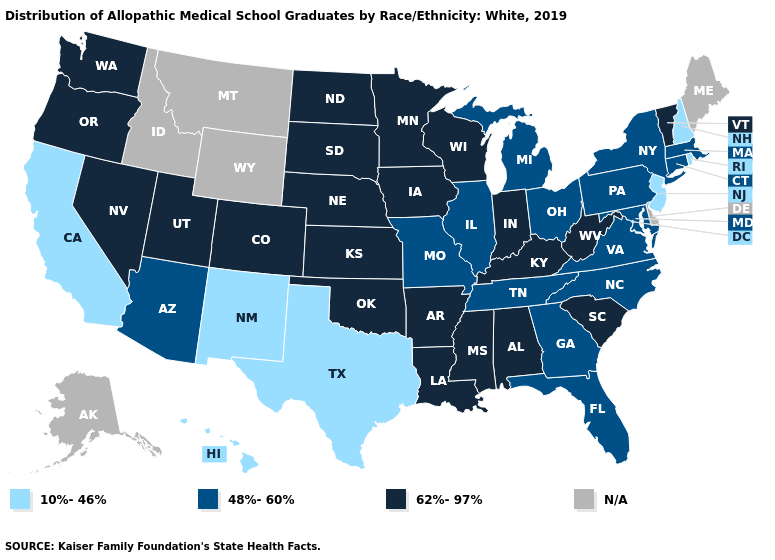Name the states that have a value in the range 10%-46%?
Quick response, please. California, Hawaii, New Hampshire, New Jersey, New Mexico, Rhode Island, Texas. Does the map have missing data?
Answer briefly. Yes. What is the lowest value in the South?
Give a very brief answer. 10%-46%. What is the value of Hawaii?
Answer briefly. 10%-46%. Name the states that have a value in the range 48%-60%?
Keep it brief. Arizona, Connecticut, Florida, Georgia, Illinois, Maryland, Massachusetts, Michigan, Missouri, New York, North Carolina, Ohio, Pennsylvania, Tennessee, Virginia. Name the states that have a value in the range N/A?
Give a very brief answer. Alaska, Delaware, Idaho, Maine, Montana, Wyoming. Name the states that have a value in the range 10%-46%?
Give a very brief answer. California, Hawaii, New Hampshire, New Jersey, New Mexico, Rhode Island, Texas. What is the value of Massachusetts?
Short answer required. 48%-60%. What is the value of Washington?
Keep it brief. 62%-97%. Name the states that have a value in the range 48%-60%?
Be succinct. Arizona, Connecticut, Florida, Georgia, Illinois, Maryland, Massachusetts, Michigan, Missouri, New York, North Carolina, Ohio, Pennsylvania, Tennessee, Virginia. Name the states that have a value in the range N/A?
Short answer required. Alaska, Delaware, Idaho, Maine, Montana, Wyoming. What is the value of West Virginia?
Be succinct. 62%-97%. Name the states that have a value in the range 48%-60%?
Write a very short answer. Arizona, Connecticut, Florida, Georgia, Illinois, Maryland, Massachusetts, Michigan, Missouri, New York, North Carolina, Ohio, Pennsylvania, Tennessee, Virginia. Does the map have missing data?
Concise answer only. Yes. Name the states that have a value in the range N/A?
Be succinct. Alaska, Delaware, Idaho, Maine, Montana, Wyoming. 